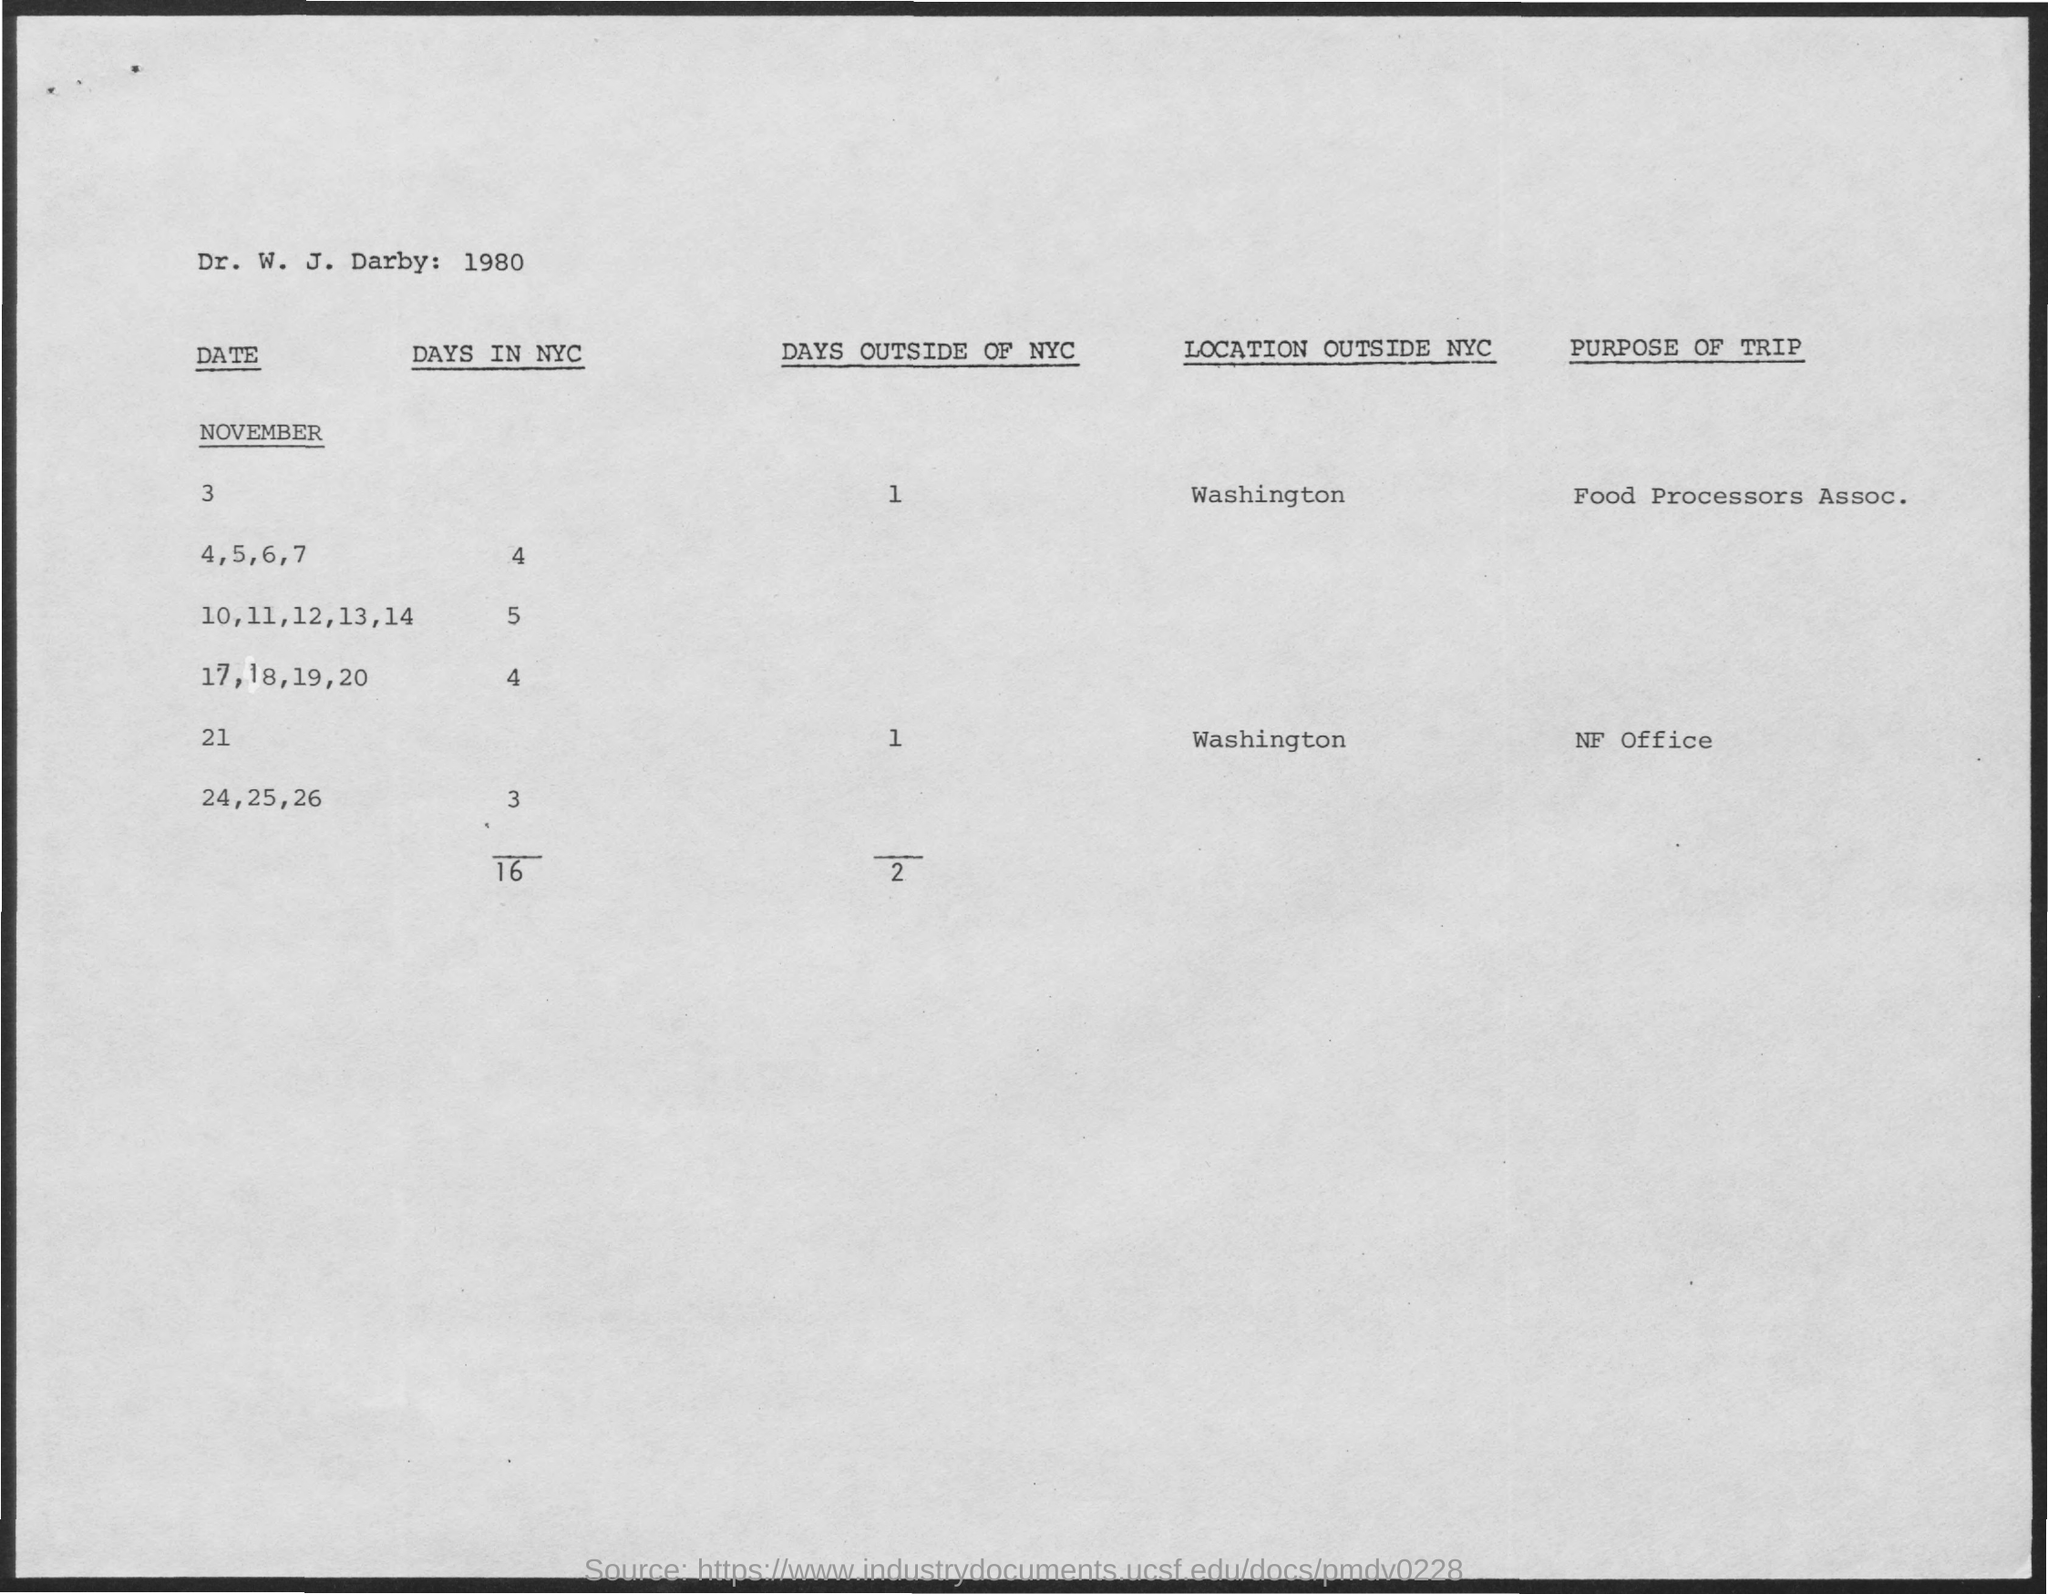Outline some significant characteristics in this image. The number of days in NYC for November 17, 18, 19, and 20 is 4. On November 21st, the number of days outside of New York City is 1. There are 5 days in NYC from November 10th to November 14th. The purpose of the trip for November 21 is to visit the NF Office. On November 4, 5, and 6, there are 4 days in NYC. 